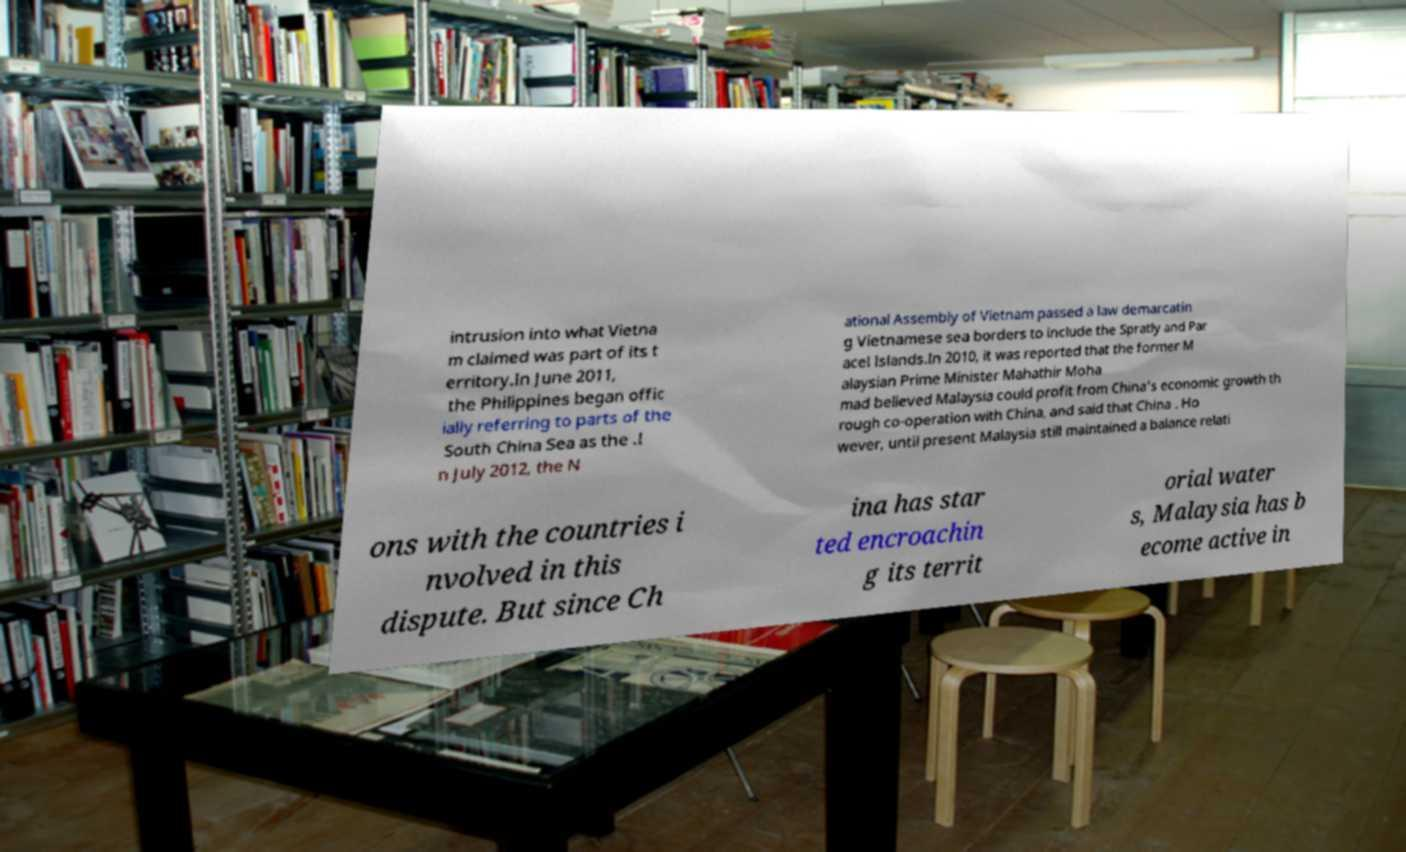Please read and relay the text visible in this image. What does it say? intrusion into what Vietna m claimed was part of its t erritory.In June 2011, the Philippines began offic ially referring to parts of the South China Sea as the .I n July 2012, the N ational Assembly of Vietnam passed a law demarcatin g Vietnamese sea borders to include the Spratly and Par acel Islands.In 2010, it was reported that the former M alaysian Prime Minister Mahathir Moha mad believed Malaysia could profit from China's economic growth th rough co-operation with China, and said that China . Ho wever, until present Malaysia still maintained a balance relati ons with the countries i nvolved in this dispute. But since Ch ina has star ted encroachin g its territ orial water s, Malaysia has b ecome active in 